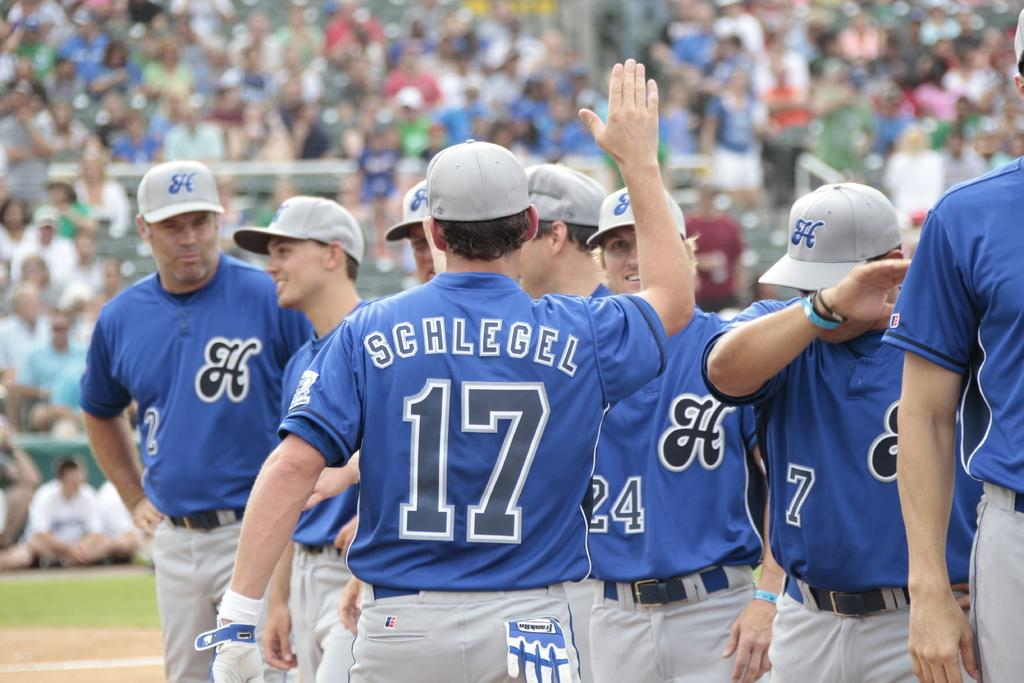<image>
Provide a brief description of the given image. The number 17 player walks along with his hand in the air. 